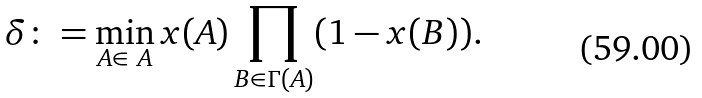<formula> <loc_0><loc_0><loc_500><loc_500>\delta \colon = \min _ { A \in \ A } x ( A ) \prod _ { B \in \Gamma ( A ) } ( 1 - x ( B ) ) .</formula> 